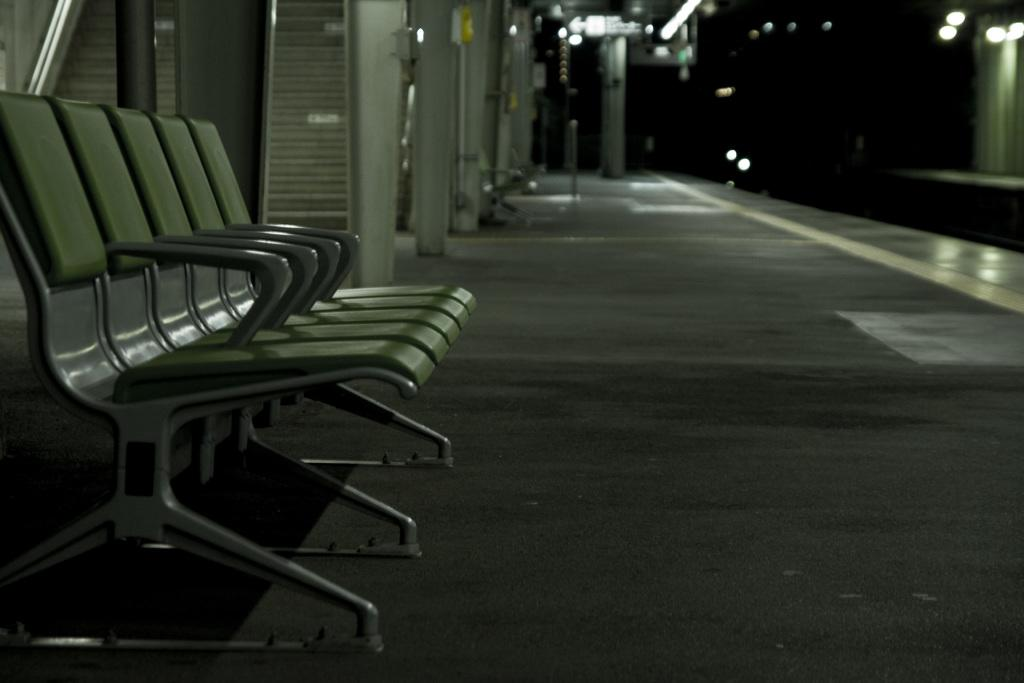What type of furniture is located on the left side of the image? There are chairs on the left side of the image. What location does the image appear to depict? The image appears to depict a railway station. What can be seen on the right side of the image? There are lights visible on the right side of the image. How would you describe the overall lighting in the image? The background of the image is dark, which suggests that the lighting is dim or low. What type of shoes can be seen in the image? There are no shoes visible in the image. Is there a jail present in the image? There is no jail depicted in the image; it appears to be a railway station. 